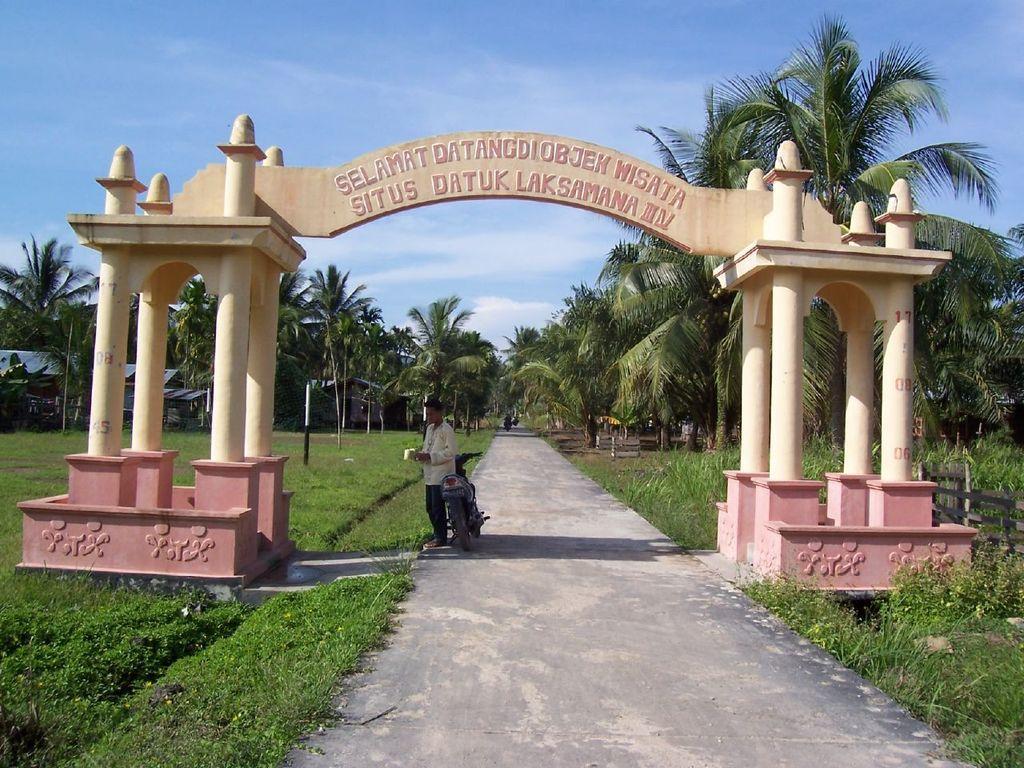Could you give a brief overview of what you see in this image? At the center of the image there is an arch, beneath the arch there is a person standing and holding some objects, beside him there is a bike on the road. In the background there are trees and a sky. 